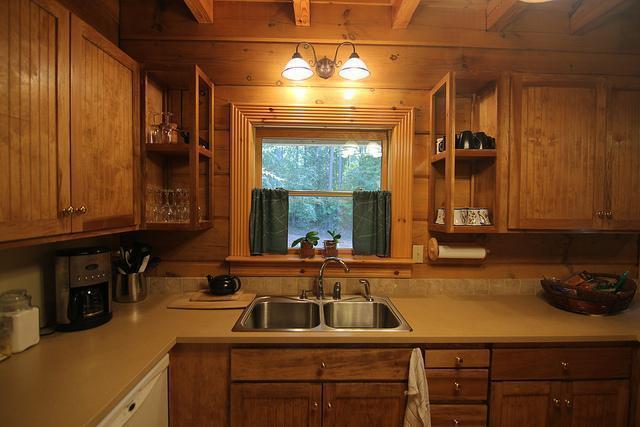What kind of sink is this?
From the following four choices, select the correct answer to address the question.
Options: Kitchen, bathroom, laundry, workstation. Kitchen. 